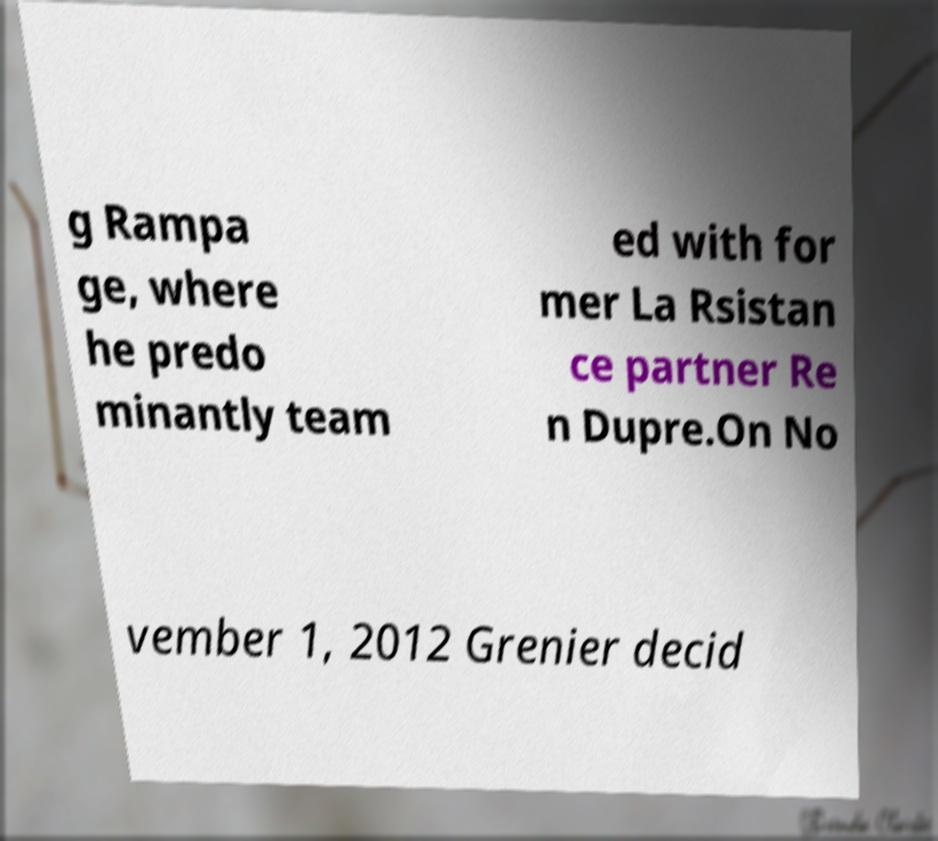Could you assist in decoding the text presented in this image and type it out clearly? g Rampa ge, where he predo minantly team ed with for mer La Rsistan ce partner Re n Dupre.On No vember 1, 2012 Grenier decid 